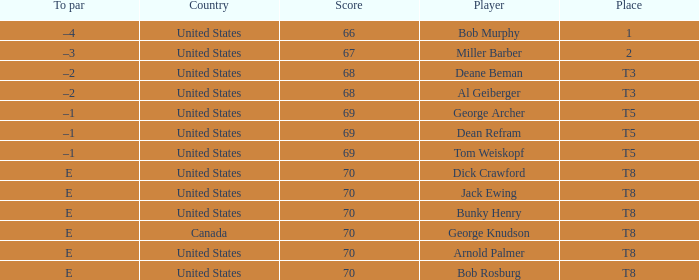Can you parse all the data within this table? {'header': ['To par', 'Country', 'Score', 'Player', 'Place'], 'rows': [['–4', 'United States', '66', 'Bob Murphy', '1'], ['–3', 'United States', '67', 'Miller Barber', '2'], ['–2', 'United States', '68', 'Deane Beman', 'T3'], ['–2', 'United States', '68', 'Al Geiberger', 'T3'], ['–1', 'United States', '69', 'George Archer', 'T5'], ['–1', 'United States', '69', 'Dean Refram', 'T5'], ['–1', 'United States', '69', 'Tom Weiskopf', 'T5'], ['E', 'United States', '70', 'Dick Crawford', 'T8'], ['E', 'United States', '70', 'Jack Ewing', 'T8'], ['E', 'United States', '70', 'Bunky Henry', 'T8'], ['E', 'Canada', '70', 'George Knudson', 'T8'], ['E', 'United States', '70', 'Arnold Palmer', 'T8'], ['E', 'United States', '70', 'Bob Rosburg', 'T8']]} When Bunky Henry of the United States scored higher than 67 and his To par was e, what was his place? T8. 